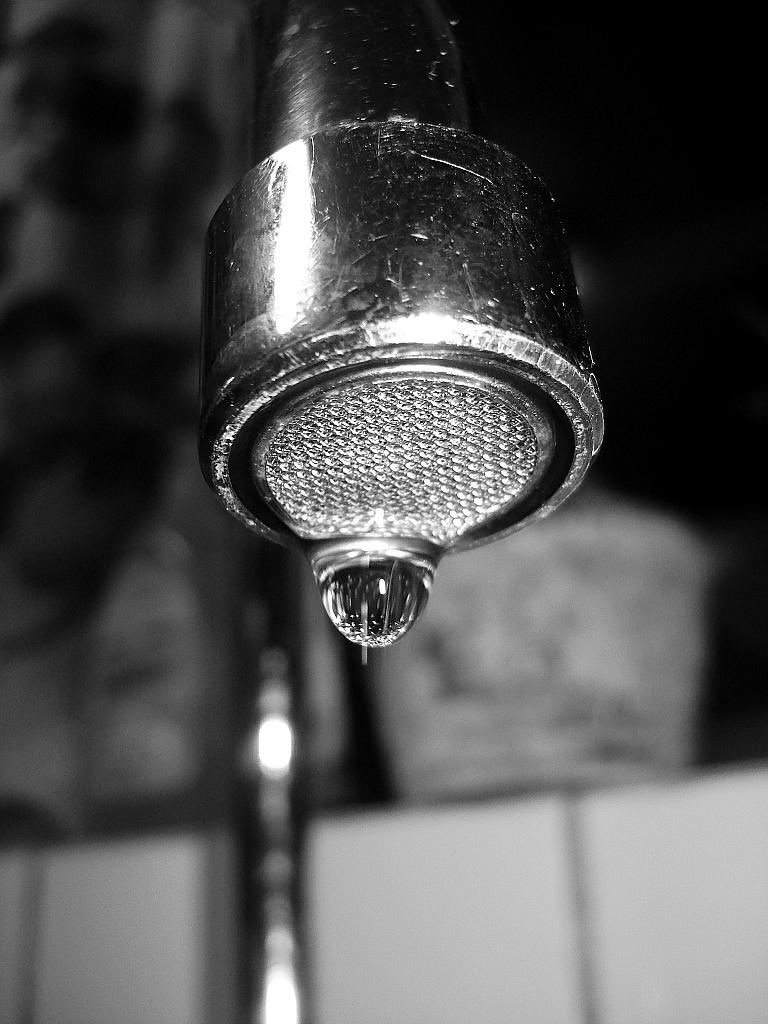What is the main object in the image? There is a water tap in the image. What else can be seen in the image besides the water tap? There is a water drop visible in the image. Can you describe the background of the image? The background of the image is blurry. Where is the clover located in the image? There is no clover present in the image. What type of blade is being used to cut the sandwich in the image? There is no sandwich or blade present in the image. 